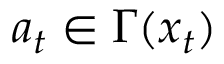Convert formula to latex. <formula><loc_0><loc_0><loc_500><loc_500>a _ { t } \in \Gamma ( x _ { t } )</formula> 